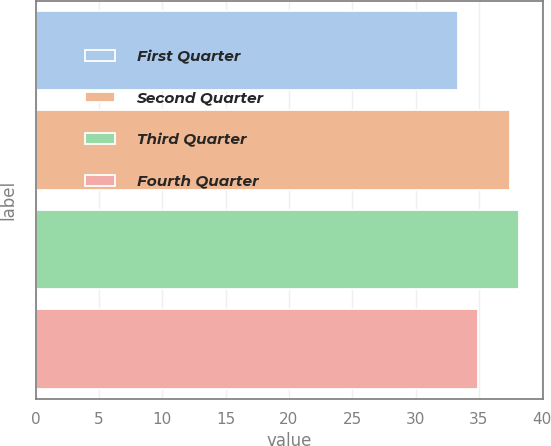Convert chart. <chart><loc_0><loc_0><loc_500><loc_500><bar_chart><fcel>First Quarter<fcel>Second Quarter<fcel>Third Quarter<fcel>Fourth Quarter<nl><fcel>33.34<fcel>37.44<fcel>38.14<fcel>34.94<nl></chart> 